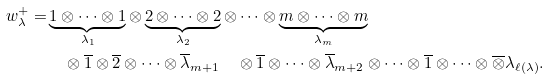Convert formula to latex. <formula><loc_0><loc_0><loc_500><loc_500>w _ { \lambda } ^ { + } = & \underbrace { 1 \otimes \cdots \otimes 1 } _ { \lambda _ { 1 } } \otimes \underbrace { 2 \otimes \cdots \otimes 2 } _ { \lambda _ { 2 } } \otimes \cdots \otimes \underbrace { m \otimes \cdots \otimes m } _ { \lambda _ { m } } \\ & \quad \otimes \overline { 1 } \otimes \overline { 2 } \otimes \cdots \otimes \overline { \lambda } _ { m + 1 } \quad \otimes \overline { 1 } \otimes \cdots \otimes \overline { \lambda } _ { m + 2 } \otimes \cdots \otimes \overline { 1 } \otimes \cdots \otimes \overline { \otimes } \lambda _ { \ell ( \lambda ) } .</formula> 